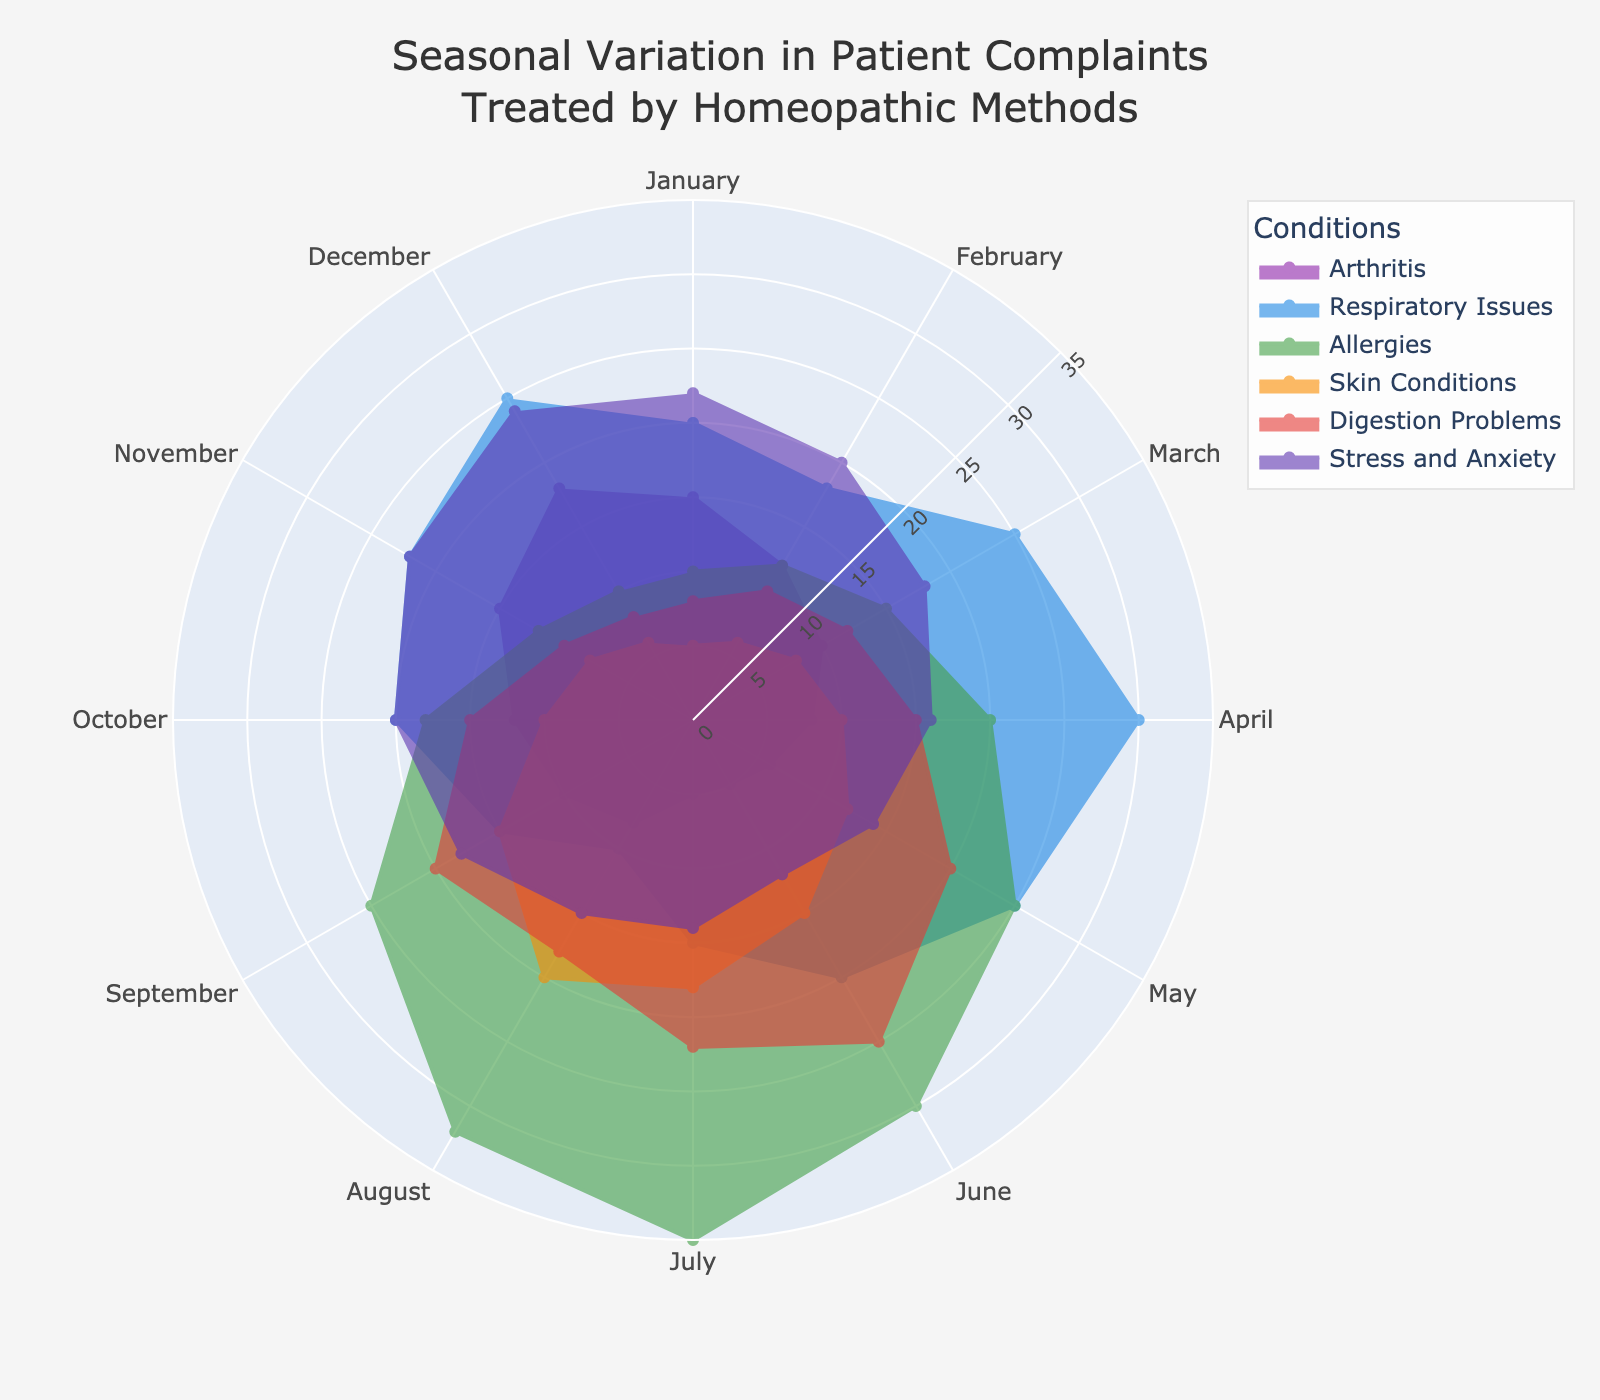What is the title of the figure? The title is usually found at the top of the figure. In this case, it states, "Seasonal Variation in Patient Complaints Treated by Homeopathic Methods."
Answer: Seasonal Variation in Patient Complaints Treated by Homeopathic Methods Which month has the highest number of Allergy complaints? By examining the polar area chart, we trace the Allergy data line (probably with a specified color) across the months. The highest point will correspond to the month with the most complaints. From the data, Allergy complaints peak in July.
Answer: July How many types of conditions are analyzed in the figure? We can count the distinct groups represented in the legend or the different lines on the chart. Six categories are analyzed: Arthritis, Respiratory Issues, Allergies, Skin Conditions, Digestion Problems, and Stress and Anxiety.
Answer: Six Which condition peaks in April? By checking the data line for each condition and identifying the maximum value that occurs in April. The Respiratory Issues line reaches maximum in April.
Answer: Respiratory Issues What is the trend for Skin Conditions throughout the year? We need to follow the Skin Conditions data line through each month and describe the observed changes. Skin Conditions show a gradual increase from January to August, then slightly decrease towards December.
Answer: Gradual increase, slight decrease towards December Which month has the lowest count for Digestion Problems? Look for the lowest point along the Digestion Problems line across all months. January has the lowest count for Digestion Problems.
Answer: January Compare the complaints for Arthritis and Stress and Anxiety in December. Which is higher? Refer to the data points for both Arthritis and Stress and Anxiety in December and compare their values. Stress and Anxiety have 24 complaints, which is higher than Arthritis with 18 complaints.
Answer: Stress and Anxiety Calculate the average number of Respiratory Issues complaints from January to March. Add the values for January, February, and March (20 + 18 + 25 = 63) and divide by 3 to get the average. The average is 63/3 = 21
Answer: 21 Which condition shows the greatest seasonal variation and what criterion did you use? Identify the condition with the largest range between its highest and lowest values. Allergies range from 10 to 35, showing the greatest variation. The criterion used is the range of values.
Answer: Allergies In which two consecutive months does the number of Digestion Problems decrease? Look for months where the data line for Digestion Problems drops from one month to the next. The number of Digestion Problems decreases from July (22) to August (18).
Answer: July to August 